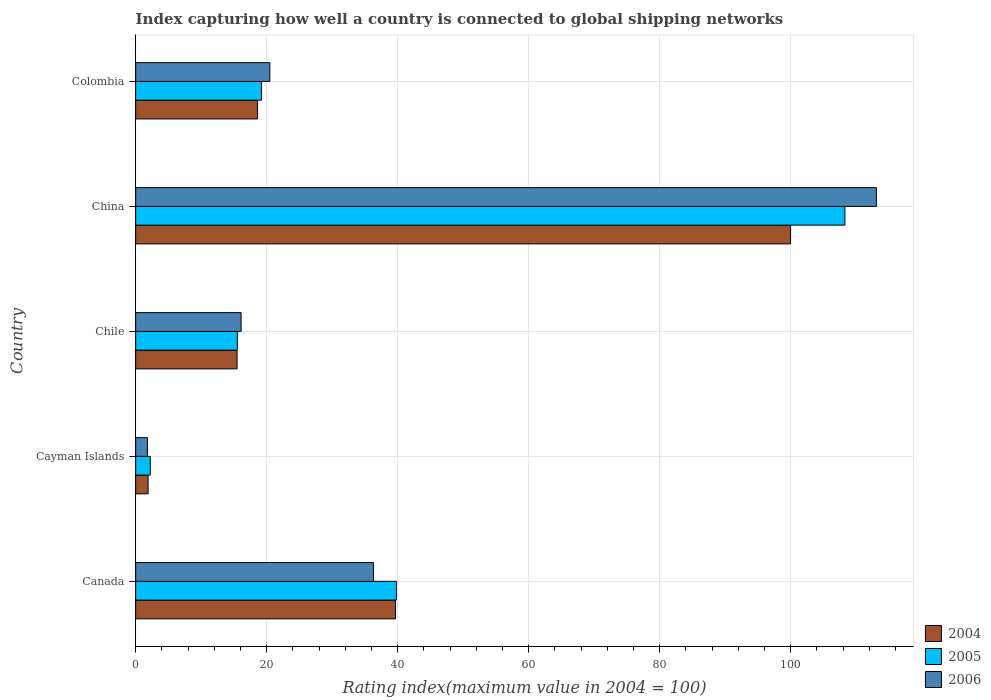How many bars are there on the 3rd tick from the top?
Ensure brevity in your answer.  3. How many bars are there on the 5th tick from the bottom?
Provide a short and direct response. 3. What is the label of the 3rd group of bars from the top?
Offer a terse response. Chile. What is the rating index in 2005 in Chile?
Give a very brief answer. 15.53. Across all countries, what is the maximum rating index in 2006?
Your answer should be compact. 113.1. Across all countries, what is the minimum rating index in 2005?
Give a very brief answer. 2.23. In which country was the rating index in 2004 maximum?
Give a very brief answer. China. In which country was the rating index in 2005 minimum?
Offer a very short reply. Cayman Islands. What is the total rating index in 2004 in the graph?
Your answer should be compact. 175.66. What is the difference between the rating index in 2004 in Canada and that in China?
Provide a short and direct response. -60.33. What is the difference between the rating index in 2005 in Canada and the rating index in 2006 in Colombia?
Offer a terse response. 19.32. What is the average rating index in 2005 per country?
Give a very brief answer. 37.01. What is the difference between the rating index in 2006 and rating index in 2004 in Canada?
Your answer should be very brief. -3.35. What is the ratio of the rating index in 2005 in Chile to that in Colombia?
Your answer should be compact. 0.81. Is the rating index in 2006 in Chile less than that in Colombia?
Offer a very short reply. Yes. What is the difference between the highest and the second highest rating index in 2005?
Make the answer very short. 68.48. What is the difference between the highest and the lowest rating index in 2006?
Offer a very short reply. 111.31. In how many countries, is the rating index in 2005 greater than the average rating index in 2005 taken over all countries?
Give a very brief answer. 2. Is the sum of the rating index in 2005 in Canada and Cayman Islands greater than the maximum rating index in 2004 across all countries?
Offer a very short reply. No. What does the 1st bar from the top in China represents?
Your answer should be compact. 2006. Are all the bars in the graph horizontal?
Keep it short and to the point. Yes. Does the graph contain any zero values?
Make the answer very short. No. Does the graph contain grids?
Make the answer very short. Yes. How many legend labels are there?
Keep it short and to the point. 3. How are the legend labels stacked?
Provide a succinct answer. Vertical. What is the title of the graph?
Keep it short and to the point. Index capturing how well a country is connected to global shipping networks. Does "2005" appear as one of the legend labels in the graph?
Offer a terse response. Yes. What is the label or title of the X-axis?
Provide a short and direct response. Rating index(maximum value in 2004 = 100). What is the Rating index(maximum value in 2004 = 100) in 2004 in Canada?
Your answer should be very brief. 39.67. What is the Rating index(maximum value in 2004 = 100) in 2005 in Canada?
Your answer should be very brief. 39.81. What is the Rating index(maximum value in 2004 = 100) of 2006 in Canada?
Offer a very short reply. 36.32. What is the Rating index(maximum value in 2004 = 100) of 2005 in Cayman Islands?
Offer a terse response. 2.23. What is the Rating index(maximum value in 2004 = 100) of 2006 in Cayman Islands?
Your answer should be very brief. 1.79. What is the Rating index(maximum value in 2004 = 100) of 2004 in Chile?
Make the answer very short. 15.48. What is the Rating index(maximum value in 2004 = 100) of 2005 in Chile?
Give a very brief answer. 15.53. What is the Rating index(maximum value in 2004 = 100) of 2005 in China?
Provide a short and direct response. 108.29. What is the Rating index(maximum value in 2004 = 100) of 2006 in China?
Ensure brevity in your answer.  113.1. What is the Rating index(maximum value in 2004 = 100) in 2004 in Colombia?
Keep it short and to the point. 18.61. What is the Rating index(maximum value in 2004 = 100) in 2006 in Colombia?
Your answer should be very brief. 20.49. Across all countries, what is the maximum Rating index(maximum value in 2004 = 100) in 2005?
Provide a succinct answer. 108.29. Across all countries, what is the maximum Rating index(maximum value in 2004 = 100) in 2006?
Provide a short and direct response. 113.1. Across all countries, what is the minimum Rating index(maximum value in 2004 = 100) of 2005?
Your response must be concise. 2.23. Across all countries, what is the minimum Rating index(maximum value in 2004 = 100) in 2006?
Make the answer very short. 1.79. What is the total Rating index(maximum value in 2004 = 100) of 2004 in the graph?
Ensure brevity in your answer.  175.66. What is the total Rating index(maximum value in 2004 = 100) of 2005 in the graph?
Provide a short and direct response. 185.06. What is the total Rating index(maximum value in 2004 = 100) in 2006 in the graph?
Make the answer very short. 187.8. What is the difference between the Rating index(maximum value in 2004 = 100) in 2004 in Canada and that in Cayman Islands?
Offer a very short reply. 37.77. What is the difference between the Rating index(maximum value in 2004 = 100) of 2005 in Canada and that in Cayman Islands?
Offer a terse response. 37.58. What is the difference between the Rating index(maximum value in 2004 = 100) in 2006 in Canada and that in Cayman Islands?
Provide a short and direct response. 34.53. What is the difference between the Rating index(maximum value in 2004 = 100) in 2004 in Canada and that in Chile?
Keep it short and to the point. 24.19. What is the difference between the Rating index(maximum value in 2004 = 100) of 2005 in Canada and that in Chile?
Provide a short and direct response. 24.28. What is the difference between the Rating index(maximum value in 2004 = 100) of 2006 in Canada and that in Chile?
Your response must be concise. 20.22. What is the difference between the Rating index(maximum value in 2004 = 100) in 2004 in Canada and that in China?
Offer a terse response. -60.33. What is the difference between the Rating index(maximum value in 2004 = 100) in 2005 in Canada and that in China?
Your response must be concise. -68.48. What is the difference between the Rating index(maximum value in 2004 = 100) in 2006 in Canada and that in China?
Offer a terse response. -76.78. What is the difference between the Rating index(maximum value in 2004 = 100) of 2004 in Canada and that in Colombia?
Make the answer very short. 21.06. What is the difference between the Rating index(maximum value in 2004 = 100) in 2005 in Canada and that in Colombia?
Ensure brevity in your answer.  20.61. What is the difference between the Rating index(maximum value in 2004 = 100) in 2006 in Canada and that in Colombia?
Keep it short and to the point. 15.83. What is the difference between the Rating index(maximum value in 2004 = 100) of 2004 in Cayman Islands and that in Chile?
Give a very brief answer. -13.58. What is the difference between the Rating index(maximum value in 2004 = 100) in 2005 in Cayman Islands and that in Chile?
Offer a very short reply. -13.3. What is the difference between the Rating index(maximum value in 2004 = 100) in 2006 in Cayman Islands and that in Chile?
Offer a terse response. -14.31. What is the difference between the Rating index(maximum value in 2004 = 100) of 2004 in Cayman Islands and that in China?
Your answer should be compact. -98.1. What is the difference between the Rating index(maximum value in 2004 = 100) in 2005 in Cayman Islands and that in China?
Offer a terse response. -106.06. What is the difference between the Rating index(maximum value in 2004 = 100) of 2006 in Cayman Islands and that in China?
Keep it short and to the point. -111.31. What is the difference between the Rating index(maximum value in 2004 = 100) in 2004 in Cayman Islands and that in Colombia?
Your response must be concise. -16.71. What is the difference between the Rating index(maximum value in 2004 = 100) of 2005 in Cayman Islands and that in Colombia?
Provide a short and direct response. -16.97. What is the difference between the Rating index(maximum value in 2004 = 100) in 2006 in Cayman Islands and that in Colombia?
Give a very brief answer. -18.7. What is the difference between the Rating index(maximum value in 2004 = 100) of 2004 in Chile and that in China?
Your answer should be very brief. -84.52. What is the difference between the Rating index(maximum value in 2004 = 100) in 2005 in Chile and that in China?
Offer a terse response. -92.76. What is the difference between the Rating index(maximum value in 2004 = 100) in 2006 in Chile and that in China?
Your answer should be very brief. -97. What is the difference between the Rating index(maximum value in 2004 = 100) of 2004 in Chile and that in Colombia?
Offer a very short reply. -3.13. What is the difference between the Rating index(maximum value in 2004 = 100) of 2005 in Chile and that in Colombia?
Your response must be concise. -3.67. What is the difference between the Rating index(maximum value in 2004 = 100) of 2006 in Chile and that in Colombia?
Offer a terse response. -4.39. What is the difference between the Rating index(maximum value in 2004 = 100) in 2004 in China and that in Colombia?
Your response must be concise. 81.39. What is the difference between the Rating index(maximum value in 2004 = 100) of 2005 in China and that in Colombia?
Ensure brevity in your answer.  89.09. What is the difference between the Rating index(maximum value in 2004 = 100) in 2006 in China and that in Colombia?
Make the answer very short. 92.61. What is the difference between the Rating index(maximum value in 2004 = 100) in 2004 in Canada and the Rating index(maximum value in 2004 = 100) in 2005 in Cayman Islands?
Your answer should be compact. 37.44. What is the difference between the Rating index(maximum value in 2004 = 100) of 2004 in Canada and the Rating index(maximum value in 2004 = 100) of 2006 in Cayman Islands?
Make the answer very short. 37.88. What is the difference between the Rating index(maximum value in 2004 = 100) of 2005 in Canada and the Rating index(maximum value in 2004 = 100) of 2006 in Cayman Islands?
Your answer should be compact. 38.02. What is the difference between the Rating index(maximum value in 2004 = 100) of 2004 in Canada and the Rating index(maximum value in 2004 = 100) of 2005 in Chile?
Keep it short and to the point. 24.14. What is the difference between the Rating index(maximum value in 2004 = 100) of 2004 in Canada and the Rating index(maximum value in 2004 = 100) of 2006 in Chile?
Your answer should be compact. 23.57. What is the difference between the Rating index(maximum value in 2004 = 100) of 2005 in Canada and the Rating index(maximum value in 2004 = 100) of 2006 in Chile?
Offer a very short reply. 23.71. What is the difference between the Rating index(maximum value in 2004 = 100) in 2004 in Canada and the Rating index(maximum value in 2004 = 100) in 2005 in China?
Keep it short and to the point. -68.62. What is the difference between the Rating index(maximum value in 2004 = 100) in 2004 in Canada and the Rating index(maximum value in 2004 = 100) in 2006 in China?
Ensure brevity in your answer.  -73.43. What is the difference between the Rating index(maximum value in 2004 = 100) in 2005 in Canada and the Rating index(maximum value in 2004 = 100) in 2006 in China?
Your answer should be compact. -73.29. What is the difference between the Rating index(maximum value in 2004 = 100) in 2004 in Canada and the Rating index(maximum value in 2004 = 100) in 2005 in Colombia?
Provide a short and direct response. 20.47. What is the difference between the Rating index(maximum value in 2004 = 100) in 2004 in Canada and the Rating index(maximum value in 2004 = 100) in 2006 in Colombia?
Offer a very short reply. 19.18. What is the difference between the Rating index(maximum value in 2004 = 100) of 2005 in Canada and the Rating index(maximum value in 2004 = 100) of 2006 in Colombia?
Provide a succinct answer. 19.32. What is the difference between the Rating index(maximum value in 2004 = 100) in 2004 in Cayman Islands and the Rating index(maximum value in 2004 = 100) in 2005 in Chile?
Ensure brevity in your answer.  -13.63. What is the difference between the Rating index(maximum value in 2004 = 100) of 2005 in Cayman Islands and the Rating index(maximum value in 2004 = 100) of 2006 in Chile?
Offer a very short reply. -13.87. What is the difference between the Rating index(maximum value in 2004 = 100) of 2004 in Cayman Islands and the Rating index(maximum value in 2004 = 100) of 2005 in China?
Keep it short and to the point. -106.39. What is the difference between the Rating index(maximum value in 2004 = 100) in 2004 in Cayman Islands and the Rating index(maximum value in 2004 = 100) in 2006 in China?
Your answer should be very brief. -111.2. What is the difference between the Rating index(maximum value in 2004 = 100) in 2005 in Cayman Islands and the Rating index(maximum value in 2004 = 100) in 2006 in China?
Provide a short and direct response. -110.87. What is the difference between the Rating index(maximum value in 2004 = 100) in 2004 in Cayman Islands and the Rating index(maximum value in 2004 = 100) in 2005 in Colombia?
Provide a succinct answer. -17.3. What is the difference between the Rating index(maximum value in 2004 = 100) in 2004 in Cayman Islands and the Rating index(maximum value in 2004 = 100) in 2006 in Colombia?
Offer a very short reply. -18.59. What is the difference between the Rating index(maximum value in 2004 = 100) of 2005 in Cayman Islands and the Rating index(maximum value in 2004 = 100) of 2006 in Colombia?
Ensure brevity in your answer.  -18.26. What is the difference between the Rating index(maximum value in 2004 = 100) in 2004 in Chile and the Rating index(maximum value in 2004 = 100) in 2005 in China?
Make the answer very short. -92.81. What is the difference between the Rating index(maximum value in 2004 = 100) in 2004 in Chile and the Rating index(maximum value in 2004 = 100) in 2006 in China?
Your answer should be compact. -97.62. What is the difference between the Rating index(maximum value in 2004 = 100) of 2005 in Chile and the Rating index(maximum value in 2004 = 100) of 2006 in China?
Provide a succinct answer. -97.57. What is the difference between the Rating index(maximum value in 2004 = 100) in 2004 in Chile and the Rating index(maximum value in 2004 = 100) in 2005 in Colombia?
Provide a short and direct response. -3.72. What is the difference between the Rating index(maximum value in 2004 = 100) in 2004 in Chile and the Rating index(maximum value in 2004 = 100) in 2006 in Colombia?
Your response must be concise. -5.01. What is the difference between the Rating index(maximum value in 2004 = 100) in 2005 in Chile and the Rating index(maximum value in 2004 = 100) in 2006 in Colombia?
Give a very brief answer. -4.96. What is the difference between the Rating index(maximum value in 2004 = 100) of 2004 in China and the Rating index(maximum value in 2004 = 100) of 2005 in Colombia?
Ensure brevity in your answer.  80.8. What is the difference between the Rating index(maximum value in 2004 = 100) of 2004 in China and the Rating index(maximum value in 2004 = 100) of 2006 in Colombia?
Ensure brevity in your answer.  79.51. What is the difference between the Rating index(maximum value in 2004 = 100) in 2005 in China and the Rating index(maximum value in 2004 = 100) in 2006 in Colombia?
Ensure brevity in your answer.  87.8. What is the average Rating index(maximum value in 2004 = 100) of 2004 per country?
Give a very brief answer. 35.13. What is the average Rating index(maximum value in 2004 = 100) of 2005 per country?
Your answer should be compact. 37.01. What is the average Rating index(maximum value in 2004 = 100) of 2006 per country?
Your answer should be compact. 37.56. What is the difference between the Rating index(maximum value in 2004 = 100) in 2004 and Rating index(maximum value in 2004 = 100) in 2005 in Canada?
Offer a very short reply. -0.14. What is the difference between the Rating index(maximum value in 2004 = 100) in 2004 and Rating index(maximum value in 2004 = 100) in 2006 in Canada?
Give a very brief answer. 3.35. What is the difference between the Rating index(maximum value in 2004 = 100) in 2005 and Rating index(maximum value in 2004 = 100) in 2006 in Canada?
Your answer should be very brief. 3.49. What is the difference between the Rating index(maximum value in 2004 = 100) of 2004 and Rating index(maximum value in 2004 = 100) of 2005 in Cayman Islands?
Offer a terse response. -0.33. What is the difference between the Rating index(maximum value in 2004 = 100) in 2004 and Rating index(maximum value in 2004 = 100) in 2006 in Cayman Islands?
Give a very brief answer. 0.11. What is the difference between the Rating index(maximum value in 2004 = 100) of 2005 and Rating index(maximum value in 2004 = 100) of 2006 in Cayman Islands?
Your answer should be very brief. 0.44. What is the difference between the Rating index(maximum value in 2004 = 100) of 2004 and Rating index(maximum value in 2004 = 100) of 2006 in Chile?
Your response must be concise. -0.62. What is the difference between the Rating index(maximum value in 2004 = 100) of 2005 and Rating index(maximum value in 2004 = 100) of 2006 in Chile?
Your answer should be compact. -0.57. What is the difference between the Rating index(maximum value in 2004 = 100) in 2004 and Rating index(maximum value in 2004 = 100) in 2005 in China?
Your answer should be compact. -8.29. What is the difference between the Rating index(maximum value in 2004 = 100) in 2004 and Rating index(maximum value in 2004 = 100) in 2006 in China?
Offer a terse response. -13.1. What is the difference between the Rating index(maximum value in 2004 = 100) in 2005 and Rating index(maximum value in 2004 = 100) in 2006 in China?
Your answer should be very brief. -4.81. What is the difference between the Rating index(maximum value in 2004 = 100) of 2004 and Rating index(maximum value in 2004 = 100) of 2005 in Colombia?
Provide a succinct answer. -0.59. What is the difference between the Rating index(maximum value in 2004 = 100) of 2004 and Rating index(maximum value in 2004 = 100) of 2006 in Colombia?
Make the answer very short. -1.88. What is the difference between the Rating index(maximum value in 2004 = 100) in 2005 and Rating index(maximum value in 2004 = 100) in 2006 in Colombia?
Keep it short and to the point. -1.29. What is the ratio of the Rating index(maximum value in 2004 = 100) in 2004 in Canada to that in Cayman Islands?
Your answer should be very brief. 20.88. What is the ratio of the Rating index(maximum value in 2004 = 100) of 2005 in Canada to that in Cayman Islands?
Keep it short and to the point. 17.85. What is the ratio of the Rating index(maximum value in 2004 = 100) in 2006 in Canada to that in Cayman Islands?
Give a very brief answer. 20.29. What is the ratio of the Rating index(maximum value in 2004 = 100) in 2004 in Canada to that in Chile?
Offer a very short reply. 2.56. What is the ratio of the Rating index(maximum value in 2004 = 100) of 2005 in Canada to that in Chile?
Your response must be concise. 2.56. What is the ratio of the Rating index(maximum value in 2004 = 100) of 2006 in Canada to that in Chile?
Your response must be concise. 2.26. What is the ratio of the Rating index(maximum value in 2004 = 100) in 2004 in Canada to that in China?
Offer a terse response. 0.4. What is the ratio of the Rating index(maximum value in 2004 = 100) of 2005 in Canada to that in China?
Offer a very short reply. 0.37. What is the ratio of the Rating index(maximum value in 2004 = 100) of 2006 in Canada to that in China?
Offer a terse response. 0.32. What is the ratio of the Rating index(maximum value in 2004 = 100) in 2004 in Canada to that in Colombia?
Your response must be concise. 2.13. What is the ratio of the Rating index(maximum value in 2004 = 100) of 2005 in Canada to that in Colombia?
Your response must be concise. 2.07. What is the ratio of the Rating index(maximum value in 2004 = 100) of 2006 in Canada to that in Colombia?
Your answer should be compact. 1.77. What is the ratio of the Rating index(maximum value in 2004 = 100) of 2004 in Cayman Islands to that in Chile?
Keep it short and to the point. 0.12. What is the ratio of the Rating index(maximum value in 2004 = 100) in 2005 in Cayman Islands to that in Chile?
Make the answer very short. 0.14. What is the ratio of the Rating index(maximum value in 2004 = 100) in 2006 in Cayman Islands to that in Chile?
Provide a short and direct response. 0.11. What is the ratio of the Rating index(maximum value in 2004 = 100) of 2004 in Cayman Islands to that in China?
Offer a very short reply. 0.02. What is the ratio of the Rating index(maximum value in 2004 = 100) of 2005 in Cayman Islands to that in China?
Offer a very short reply. 0.02. What is the ratio of the Rating index(maximum value in 2004 = 100) in 2006 in Cayman Islands to that in China?
Offer a very short reply. 0.02. What is the ratio of the Rating index(maximum value in 2004 = 100) in 2004 in Cayman Islands to that in Colombia?
Provide a succinct answer. 0.1. What is the ratio of the Rating index(maximum value in 2004 = 100) in 2005 in Cayman Islands to that in Colombia?
Ensure brevity in your answer.  0.12. What is the ratio of the Rating index(maximum value in 2004 = 100) of 2006 in Cayman Islands to that in Colombia?
Give a very brief answer. 0.09. What is the ratio of the Rating index(maximum value in 2004 = 100) of 2004 in Chile to that in China?
Make the answer very short. 0.15. What is the ratio of the Rating index(maximum value in 2004 = 100) in 2005 in Chile to that in China?
Ensure brevity in your answer.  0.14. What is the ratio of the Rating index(maximum value in 2004 = 100) in 2006 in Chile to that in China?
Keep it short and to the point. 0.14. What is the ratio of the Rating index(maximum value in 2004 = 100) in 2004 in Chile to that in Colombia?
Your answer should be very brief. 0.83. What is the ratio of the Rating index(maximum value in 2004 = 100) of 2005 in Chile to that in Colombia?
Keep it short and to the point. 0.81. What is the ratio of the Rating index(maximum value in 2004 = 100) of 2006 in Chile to that in Colombia?
Your response must be concise. 0.79. What is the ratio of the Rating index(maximum value in 2004 = 100) of 2004 in China to that in Colombia?
Your answer should be very brief. 5.37. What is the ratio of the Rating index(maximum value in 2004 = 100) in 2005 in China to that in Colombia?
Make the answer very short. 5.64. What is the ratio of the Rating index(maximum value in 2004 = 100) in 2006 in China to that in Colombia?
Keep it short and to the point. 5.52. What is the difference between the highest and the second highest Rating index(maximum value in 2004 = 100) in 2004?
Ensure brevity in your answer.  60.33. What is the difference between the highest and the second highest Rating index(maximum value in 2004 = 100) in 2005?
Your answer should be compact. 68.48. What is the difference between the highest and the second highest Rating index(maximum value in 2004 = 100) in 2006?
Provide a succinct answer. 76.78. What is the difference between the highest and the lowest Rating index(maximum value in 2004 = 100) in 2004?
Offer a terse response. 98.1. What is the difference between the highest and the lowest Rating index(maximum value in 2004 = 100) in 2005?
Make the answer very short. 106.06. What is the difference between the highest and the lowest Rating index(maximum value in 2004 = 100) in 2006?
Make the answer very short. 111.31. 